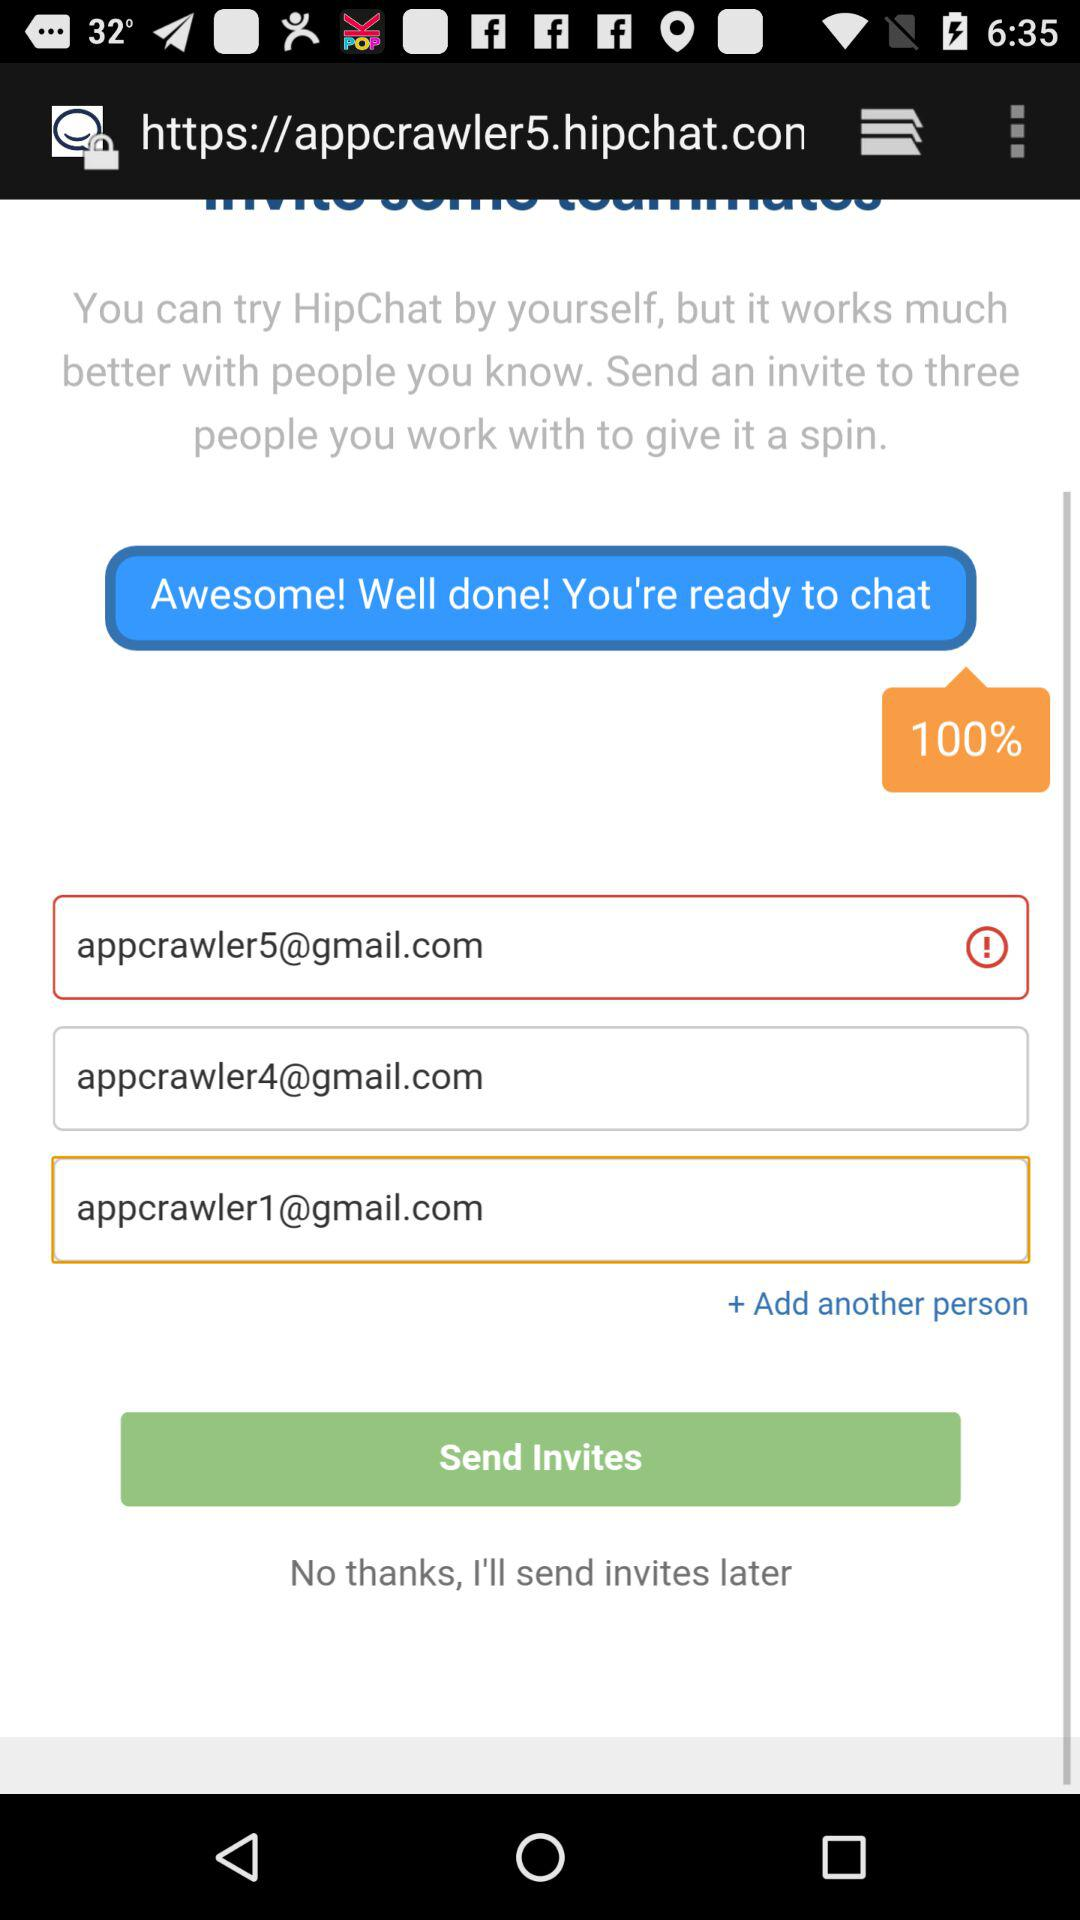How many people have I invited?
Answer the question using a single word or phrase. 3 